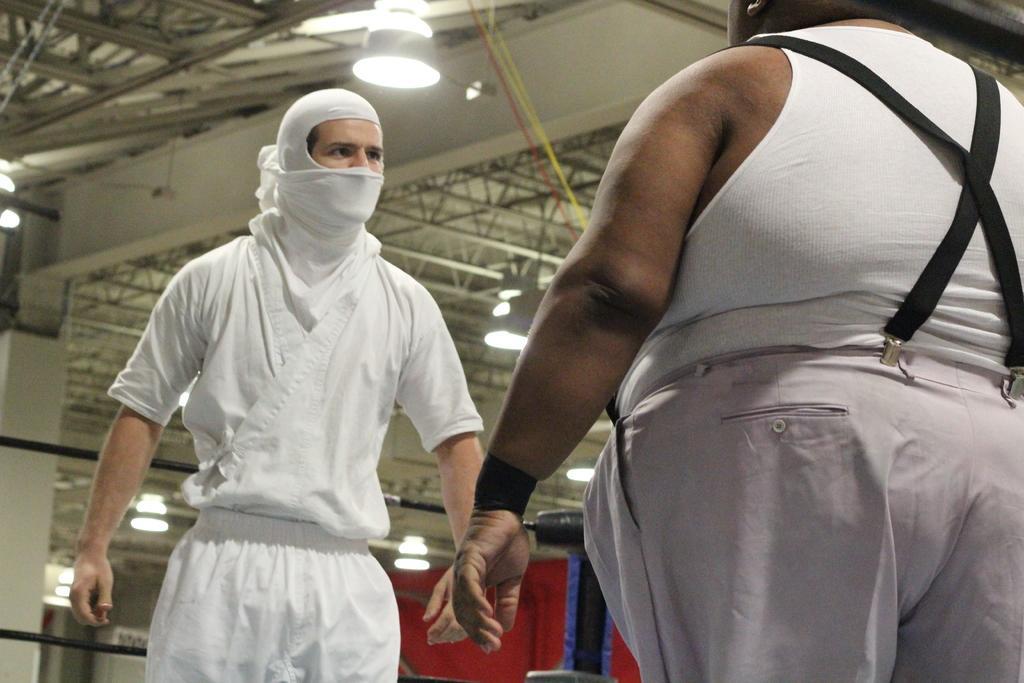Can you describe this image briefly? There are two persons standing. One person is wearing scarf. On the ceiling there are lights, rods. In the back there is a red color thing. 